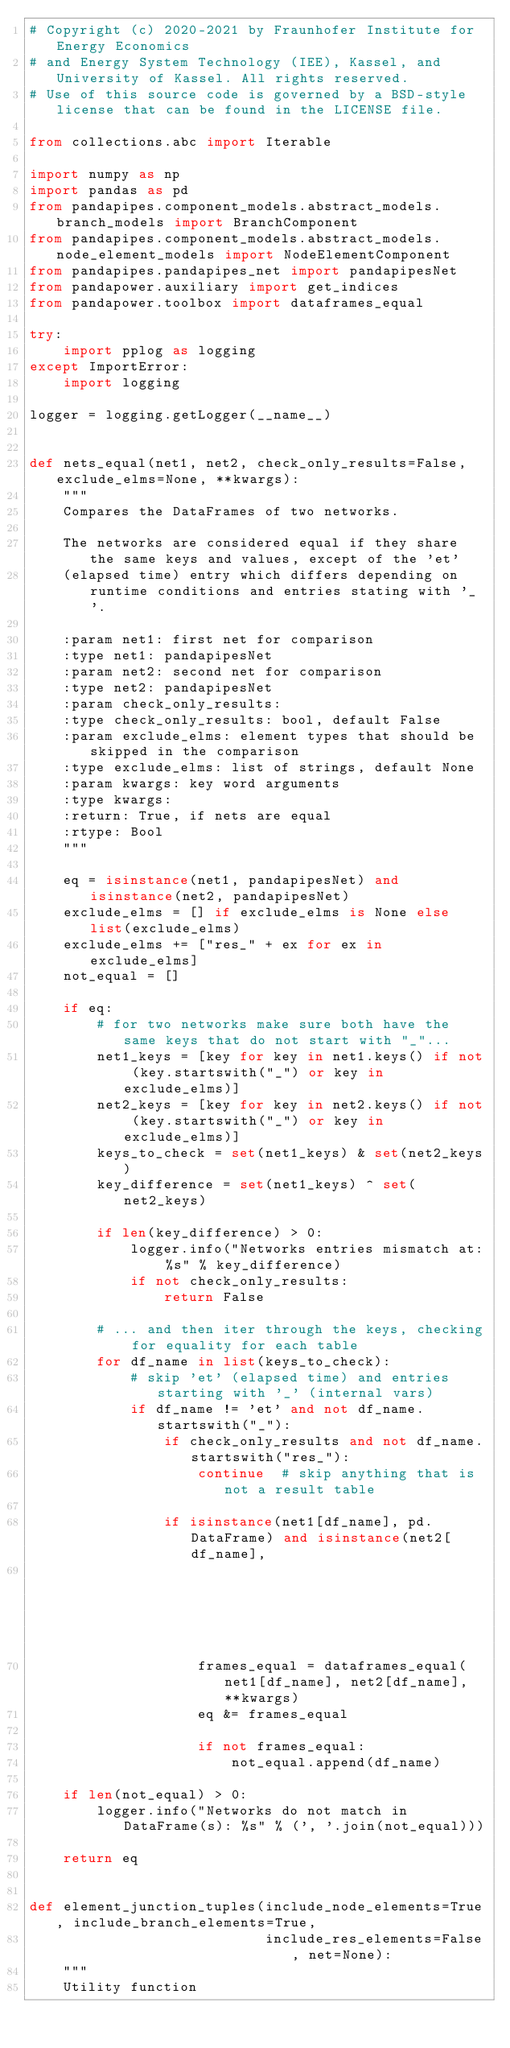<code> <loc_0><loc_0><loc_500><loc_500><_Python_># Copyright (c) 2020-2021 by Fraunhofer Institute for Energy Economics
# and Energy System Technology (IEE), Kassel, and University of Kassel. All rights reserved.
# Use of this source code is governed by a BSD-style license that can be found in the LICENSE file.

from collections.abc import Iterable

import numpy as np
import pandas as pd
from pandapipes.component_models.abstract_models.branch_models import BranchComponent
from pandapipes.component_models.abstract_models.node_element_models import NodeElementComponent
from pandapipes.pandapipes_net import pandapipesNet
from pandapower.auxiliary import get_indices
from pandapower.toolbox import dataframes_equal

try:
    import pplog as logging
except ImportError:
    import logging

logger = logging.getLogger(__name__)


def nets_equal(net1, net2, check_only_results=False, exclude_elms=None, **kwargs):
    """
    Compares the DataFrames of two networks.

    The networks are considered equal if they share the same keys and values, except of the 'et'
    (elapsed time) entry which differs depending on runtime conditions and entries stating with '_'.

    :param net1: first net for comparison
    :type net1: pandapipesNet
    :param net2: second net for comparison
    :type net2: pandapipesNet
    :param check_only_results:
    :type check_only_results: bool, default False
    :param exclude_elms: element types that should be skipped in the comparison
    :type exclude_elms: list of strings, default None
    :param kwargs: key word arguments
    :type kwargs:
    :return: True, if nets are equal
    :rtype: Bool
    """

    eq = isinstance(net1, pandapipesNet) and isinstance(net2, pandapipesNet)
    exclude_elms = [] if exclude_elms is None else list(exclude_elms)
    exclude_elms += ["res_" + ex for ex in exclude_elms]
    not_equal = []

    if eq:
        # for two networks make sure both have the same keys that do not start with "_"...
        net1_keys = [key for key in net1.keys() if not (key.startswith("_") or key in exclude_elms)]
        net2_keys = [key for key in net2.keys() if not (key.startswith("_") or key in exclude_elms)]
        keys_to_check = set(net1_keys) & set(net2_keys)
        key_difference = set(net1_keys) ^ set(net2_keys)

        if len(key_difference) > 0:
            logger.info("Networks entries mismatch at: %s" % key_difference)
            if not check_only_results:
                return False

        # ... and then iter through the keys, checking for equality for each table
        for df_name in list(keys_to_check):
            # skip 'et' (elapsed time) and entries starting with '_' (internal vars)
            if df_name != 'et' and not df_name.startswith("_"):
                if check_only_results and not df_name.startswith("res_"):
                    continue  # skip anything that is not a result table

                if isinstance(net1[df_name], pd.DataFrame) and isinstance(net2[df_name],
                                                                          pd.DataFrame):
                    frames_equal = dataframes_equal(net1[df_name], net2[df_name], **kwargs)
                    eq &= frames_equal

                    if not frames_equal:
                        not_equal.append(df_name)

    if len(not_equal) > 0:
        logger.info("Networks do not match in DataFrame(s): %s" % (', '.join(not_equal)))

    return eq


def element_junction_tuples(include_node_elements=True, include_branch_elements=True,
                            include_res_elements=False, net=None):
    """
    Utility function</code> 